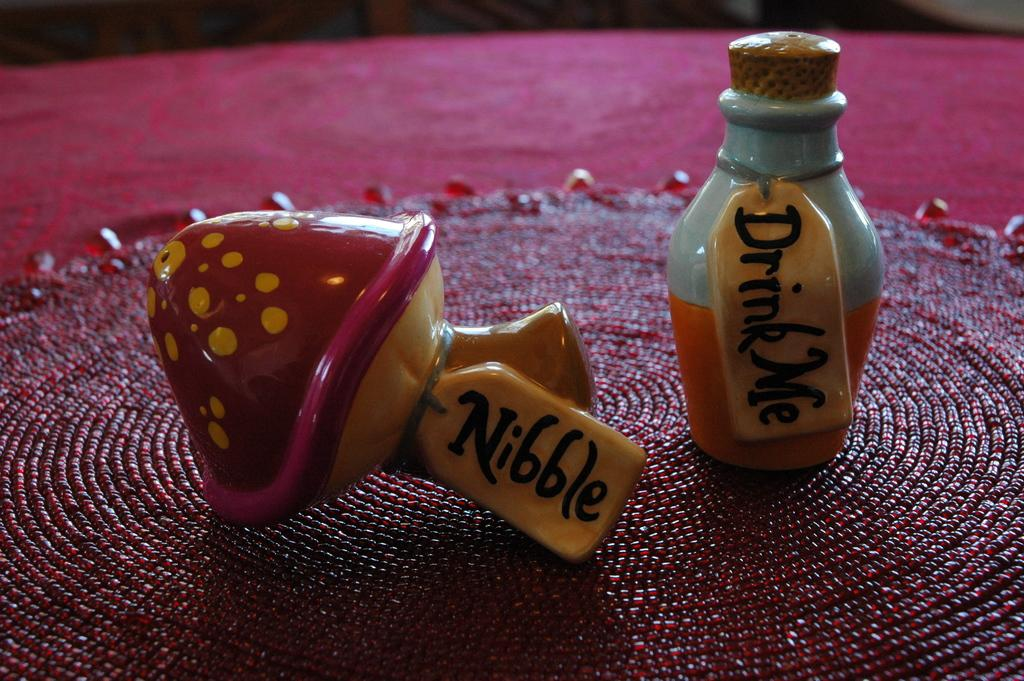<image>
Create a compact narrative representing the image presented. Two small ceramic bottles, one labeled Drink Me and the other Nibble 